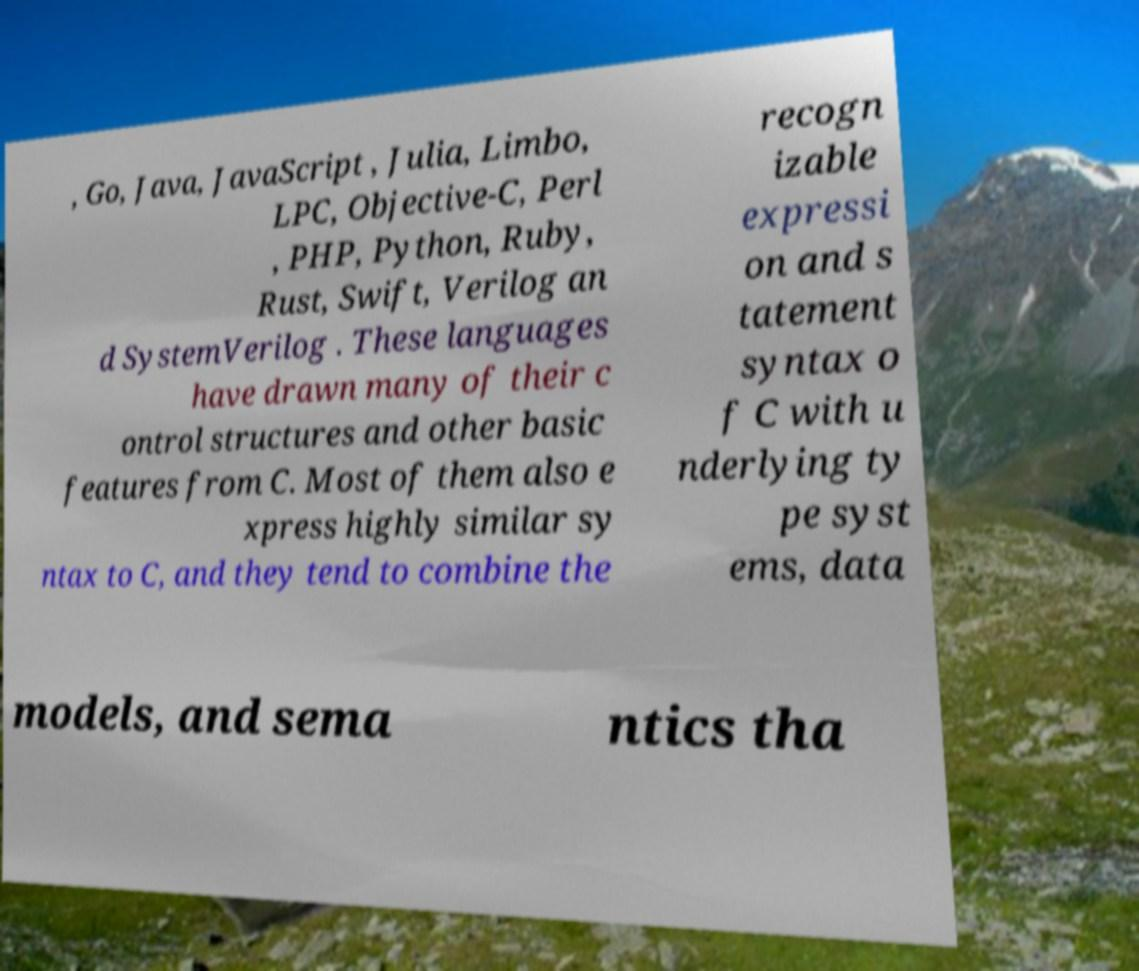What messages or text are displayed in this image? I need them in a readable, typed format. , Go, Java, JavaScript , Julia, Limbo, LPC, Objective-C, Perl , PHP, Python, Ruby, Rust, Swift, Verilog an d SystemVerilog . These languages have drawn many of their c ontrol structures and other basic features from C. Most of them also e xpress highly similar sy ntax to C, and they tend to combine the recogn izable expressi on and s tatement syntax o f C with u nderlying ty pe syst ems, data models, and sema ntics tha 